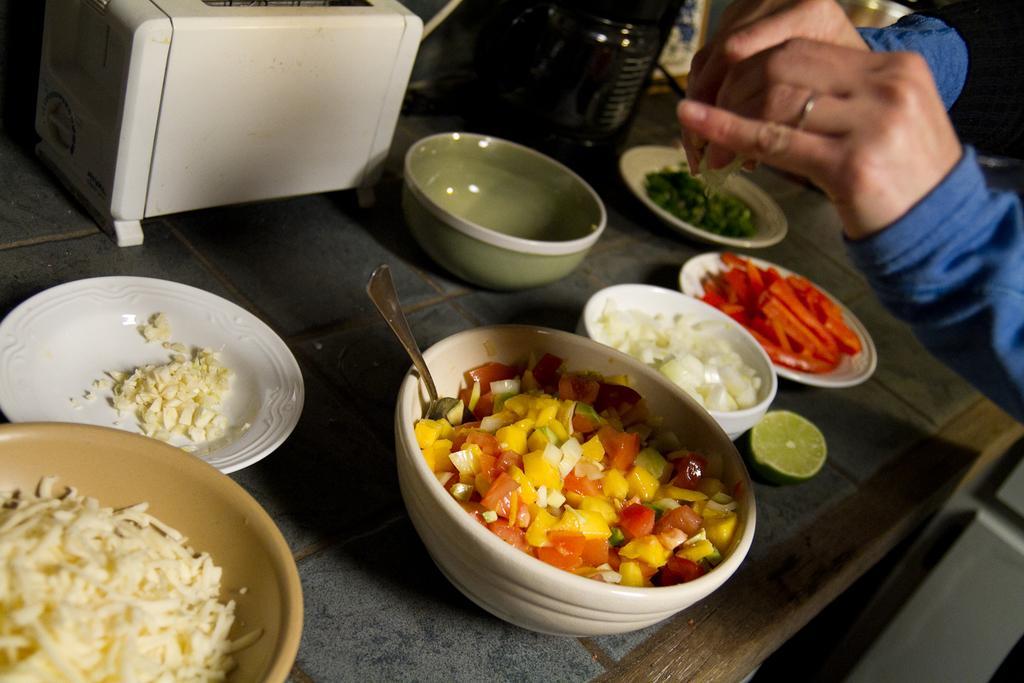Describe this image in one or two sentences. In this image, there is a table, on that table there are some bowls and there is a white color saucer, there is a white color object, at the right side there is a person standing. 